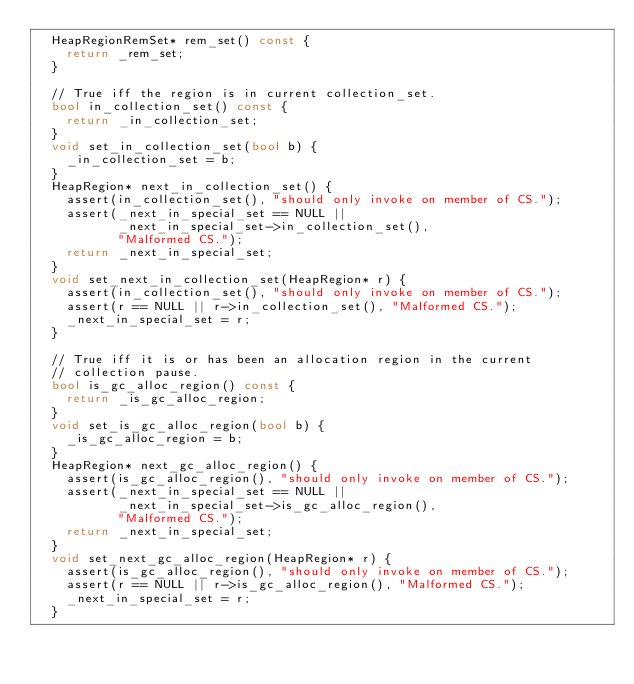<code> <loc_0><loc_0><loc_500><loc_500><_C++_>  HeapRegionRemSet* rem_set() const {
    return _rem_set;
  }

  // True iff the region is in current collection_set.
  bool in_collection_set() const {
    return _in_collection_set;
  }
  void set_in_collection_set(bool b) {
    _in_collection_set = b;
  }
  HeapRegion* next_in_collection_set() {
    assert(in_collection_set(), "should only invoke on member of CS.");
    assert(_next_in_special_set == NULL ||
           _next_in_special_set->in_collection_set(),
           "Malformed CS.");
    return _next_in_special_set;
  }
  void set_next_in_collection_set(HeapRegion* r) {
    assert(in_collection_set(), "should only invoke on member of CS.");
    assert(r == NULL || r->in_collection_set(), "Malformed CS.");
    _next_in_special_set = r;
  }

  // True iff it is or has been an allocation region in the current
  // collection pause.
  bool is_gc_alloc_region() const {
    return _is_gc_alloc_region;
  }
  void set_is_gc_alloc_region(bool b) {
    _is_gc_alloc_region = b;
  }
  HeapRegion* next_gc_alloc_region() {
    assert(is_gc_alloc_region(), "should only invoke on member of CS.");
    assert(_next_in_special_set == NULL ||
           _next_in_special_set->is_gc_alloc_region(),
           "Malformed CS.");
    return _next_in_special_set;
  }
  void set_next_gc_alloc_region(HeapRegion* r) {
    assert(is_gc_alloc_region(), "should only invoke on member of CS.");
    assert(r == NULL || r->is_gc_alloc_region(), "Malformed CS.");
    _next_in_special_set = r;
  }
</code> 